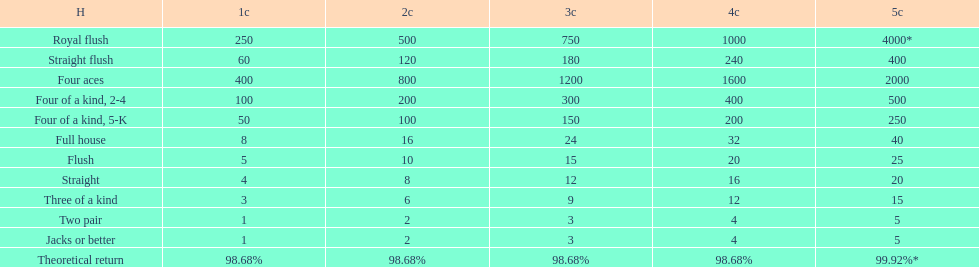The number of credits returned for a one credit bet on a royal flush are. 250. 